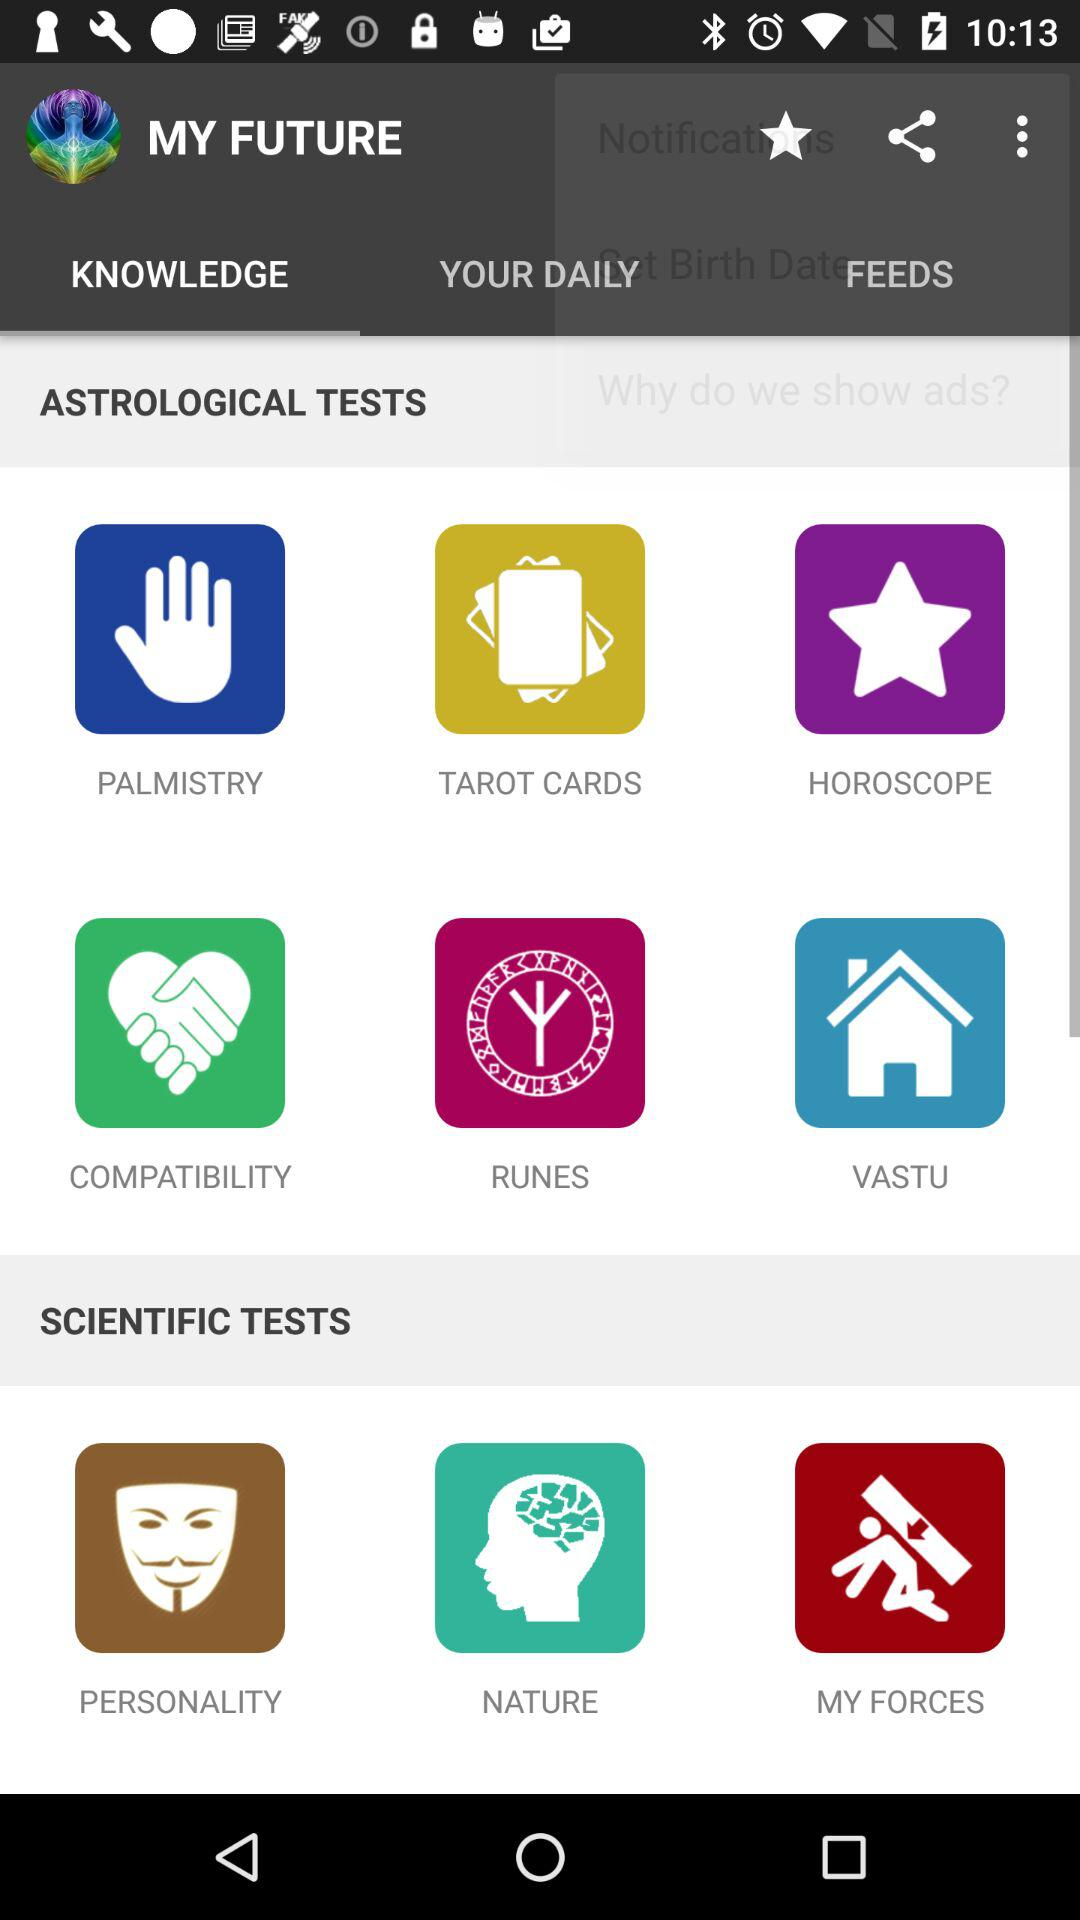What is the name of the application? The name of the application is "MY FUTURE". 